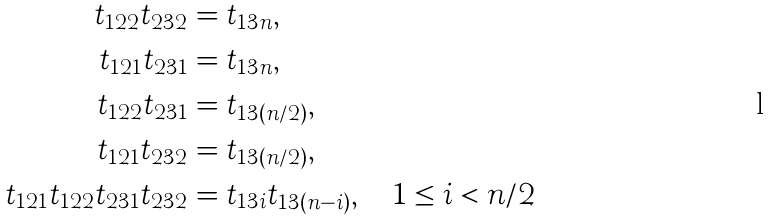Convert formula to latex. <formula><loc_0><loc_0><loc_500><loc_500>t _ { 1 2 2 } t _ { 2 3 2 } & = t _ { 1 3 n } , \\ t _ { 1 2 1 } t _ { 2 3 1 } & = t _ { 1 3 n } , \\ t _ { 1 2 2 } t _ { 2 3 1 } & = t _ { 1 3 ( n / 2 ) } , \\ t _ { 1 2 1 } t _ { 2 3 2 } & = t _ { 1 3 ( n / 2 ) } , \\ t _ { 1 2 1 } t _ { 1 2 2 } t _ { 2 3 1 } t _ { 2 3 2 } & = t _ { 1 3 i } t _ { 1 3 ( n - i ) } , \quad 1 \leq i < n / 2</formula> 